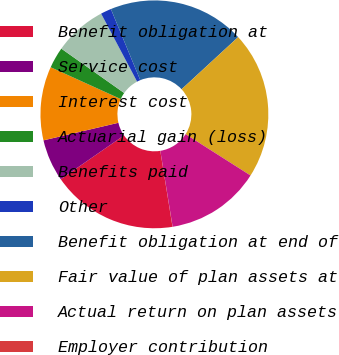Convert chart to OTSL. <chart><loc_0><loc_0><loc_500><loc_500><pie_chart><fcel>Benefit obligation at<fcel>Service cost<fcel>Interest cost<fcel>Actuarial gain (loss)<fcel>Benefits paid<fcel>Other<fcel>Benefit obligation at end of<fcel>Fair value of plan assets at<fcel>Actual return on plan assets<fcel>Employer contribution<nl><fcel>17.89%<fcel>5.98%<fcel>10.45%<fcel>3.0%<fcel>7.47%<fcel>1.51%<fcel>19.38%<fcel>20.87%<fcel>13.42%<fcel>0.02%<nl></chart> 